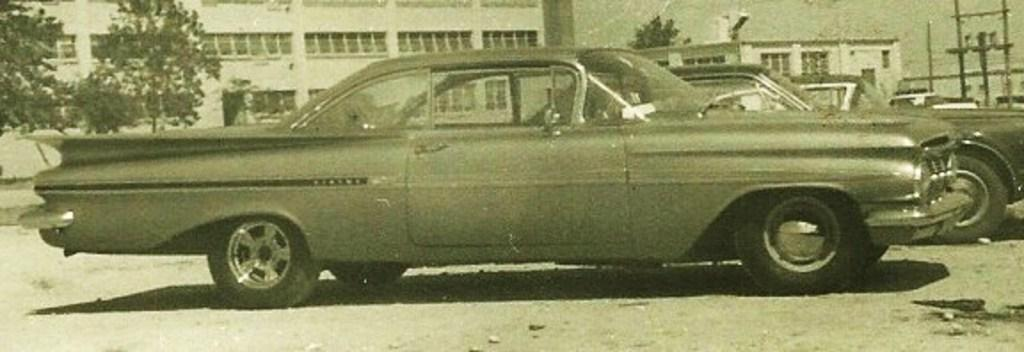What can be seen on the road in the image? There are cars parked on the road in the image. What type of natural elements are visible in the background of the image? There are trees in the background of the image. What type of man-made structures can be seen in the background of the image? There are buildings in the background of the image. What type of electrical equipment is present in the background of the image? A transformer is present in the background of the image. What part of the natural environment is visible in the background of the image? The sky is visible in the background of the image. Can you tell me how many people are sitting at the table in the image? There is no table present in the image. What type of creature is stuck in the quicksand in the image? There is no quicksand or creature present in the image. 